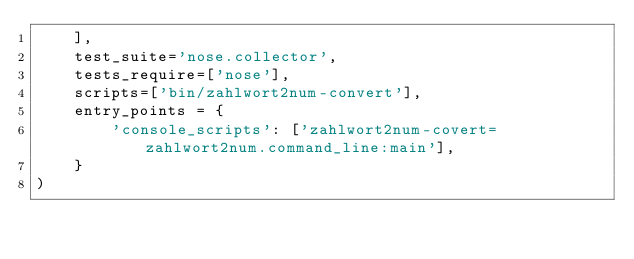Convert code to text. <code><loc_0><loc_0><loc_500><loc_500><_Python_>    ],
    test_suite='nose.collector',
    tests_require=['nose'],
    scripts=['bin/zahlwort2num-convert'],
    entry_points = {
        'console_scripts': ['zahlwort2num-covert=zahlwort2num.command_line:main'],
    }
)</code> 